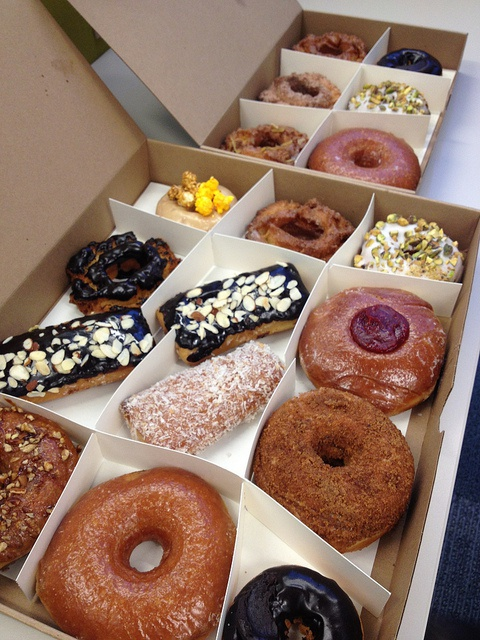Describe the objects in this image and their specific colors. I can see donut in gray, brown, and maroon tones, donut in gray, brown, maroon, and black tones, donut in gray, brown, and maroon tones, cake in gray, lightgray, tan, and darkgray tones, and cake in gray, black, and beige tones in this image. 